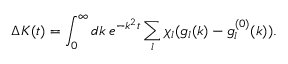Convert formula to latex. <formula><loc_0><loc_0><loc_500><loc_500>\Delta K ( t ) = \int _ { 0 } ^ { \infty } d k \, e ^ { - k ^ { 2 } t } \sum _ { l } \chi _ { l } ( g _ { l } ( k ) - g _ { l } ^ { ( 0 ) } ( k ) ) .</formula> 